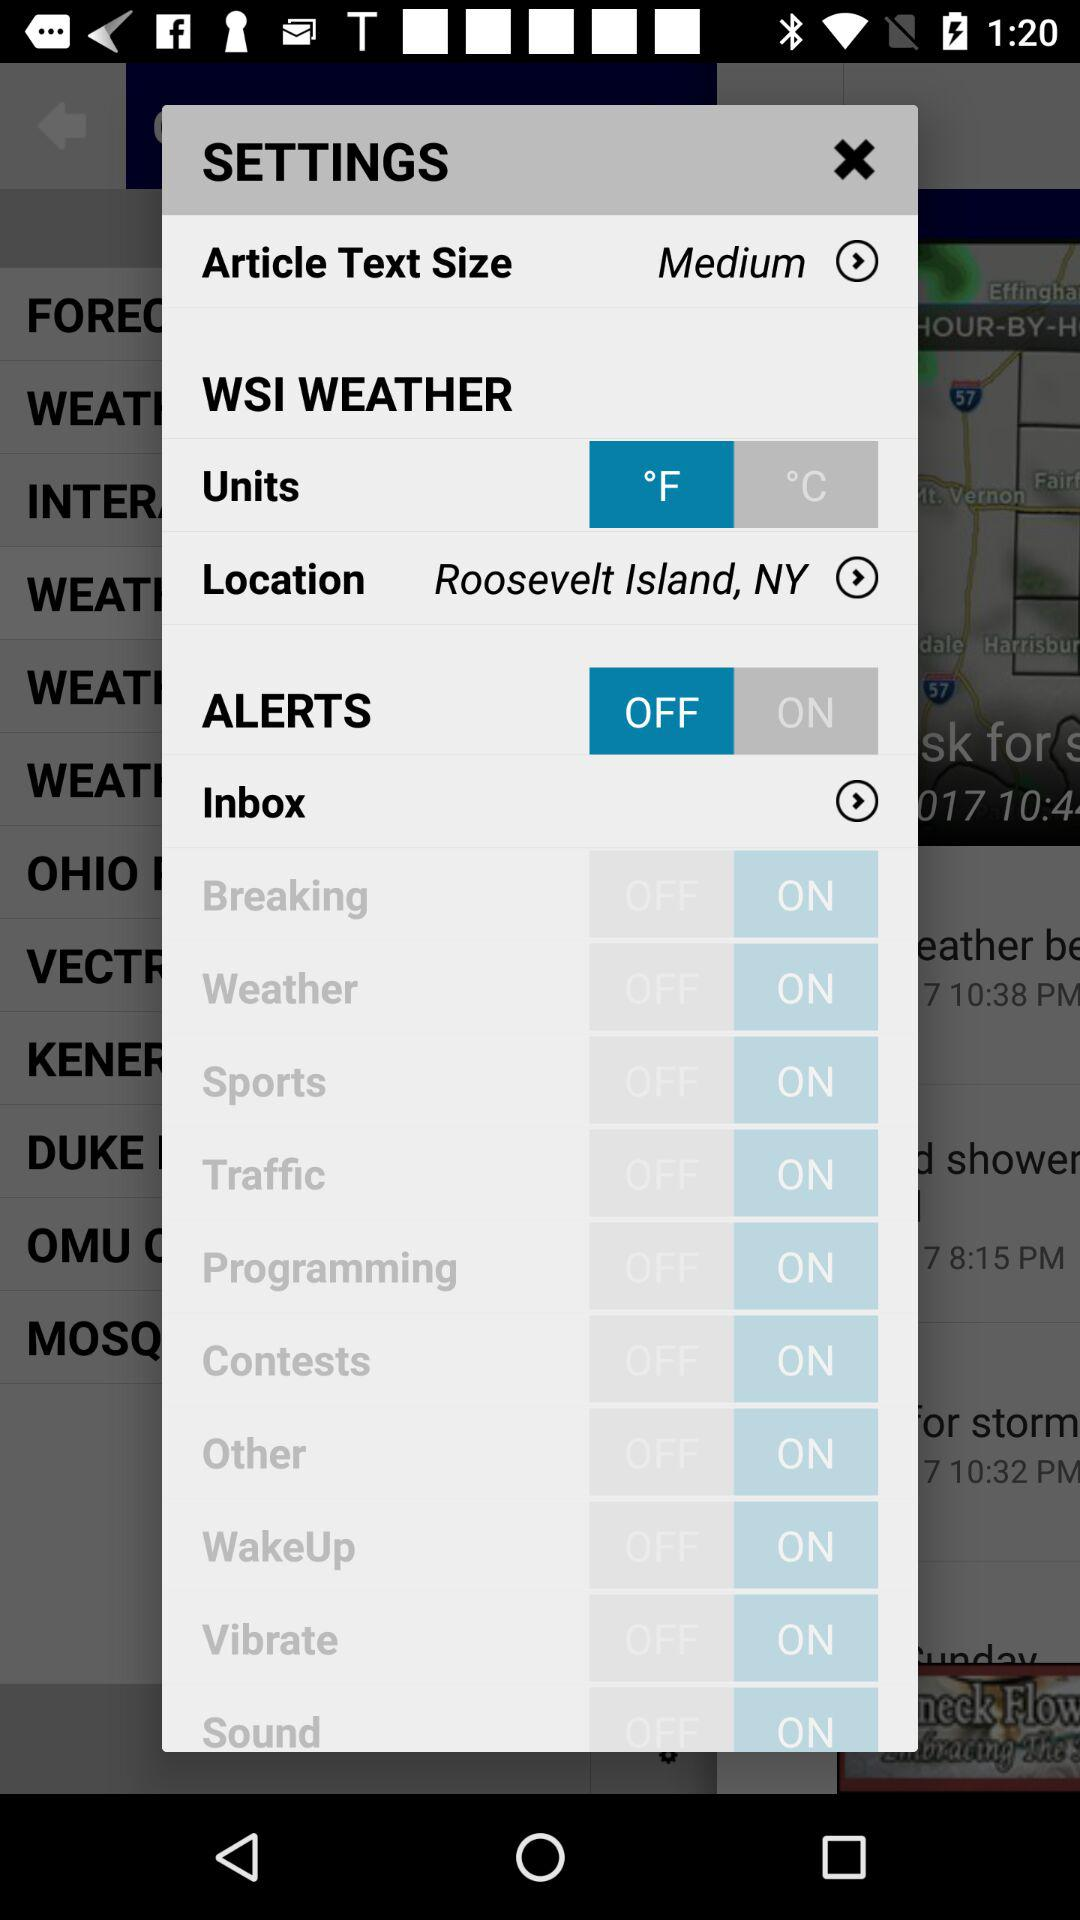What's the status of "ALERTS"? The status is "off". 